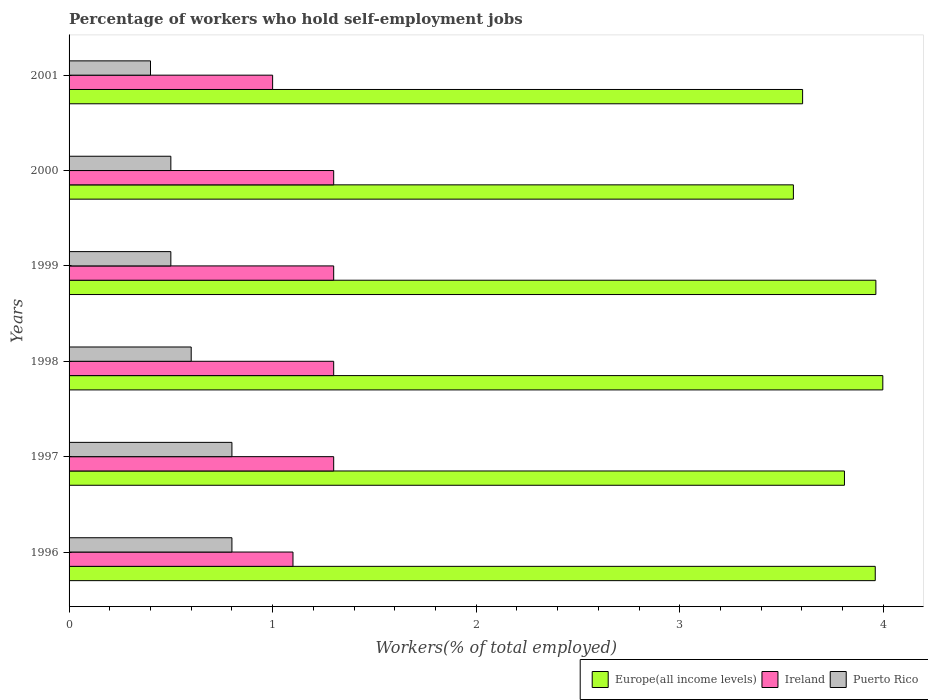How many different coloured bars are there?
Give a very brief answer. 3. How many bars are there on the 5th tick from the top?
Keep it short and to the point. 3. How many bars are there on the 3rd tick from the bottom?
Your response must be concise. 3. In how many cases, is the number of bars for a given year not equal to the number of legend labels?
Offer a very short reply. 0. What is the percentage of self-employed workers in Ireland in 1999?
Offer a very short reply. 1.3. Across all years, what is the maximum percentage of self-employed workers in Puerto Rico?
Your answer should be compact. 0.8. Across all years, what is the minimum percentage of self-employed workers in Europe(all income levels)?
Offer a terse response. 3.56. In which year was the percentage of self-employed workers in Puerto Rico maximum?
Ensure brevity in your answer.  1996. In which year was the percentage of self-employed workers in Ireland minimum?
Offer a terse response. 2001. What is the total percentage of self-employed workers in Europe(all income levels) in the graph?
Offer a very short reply. 22.89. What is the difference between the percentage of self-employed workers in Europe(all income levels) in 1996 and the percentage of self-employed workers in Puerto Rico in 1997?
Give a very brief answer. 3.16. What is the average percentage of self-employed workers in Puerto Rico per year?
Provide a short and direct response. 0.6. In the year 2001, what is the difference between the percentage of self-employed workers in Puerto Rico and percentage of self-employed workers in Ireland?
Offer a terse response. -0.6. In how many years, is the percentage of self-employed workers in Europe(all income levels) greater than 1.4 %?
Offer a terse response. 6. What is the ratio of the percentage of self-employed workers in Europe(all income levels) in 1996 to that in 1997?
Give a very brief answer. 1.04. What is the difference between the highest and the lowest percentage of self-employed workers in Ireland?
Offer a terse response. 0.3. What does the 1st bar from the top in 1997 represents?
Make the answer very short. Puerto Rico. What does the 3rd bar from the bottom in 2001 represents?
Keep it short and to the point. Puerto Rico. Is it the case that in every year, the sum of the percentage of self-employed workers in Europe(all income levels) and percentage of self-employed workers in Ireland is greater than the percentage of self-employed workers in Puerto Rico?
Provide a succinct answer. Yes. How many bars are there?
Your answer should be compact. 18. Does the graph contain any zero values?
Ensure brevity in your answer.  No. Does the graph contain grids?
Your answer should be compact. No. How are the legend labels stacked?
Make the answer very short. Horizontal. What is the title of the graph?
Give a very brief answer. Percentage of workers who hold self-employment jobs. Does "Kiribati" appear as one of the legend labels in the graph?
Offer a terse response. No. What is the label or title of the X-axis?
Provide a short and direct response. Workers(% of total employed). What is the Workers(% of total employed) of Europe(all income levels) in 1996?
Provide a succinct answer. 3.96. What is the Workers(% of total employed) of Ireland in 1996?
Your answer should be very brief. 1.1. What is the Workers(% of total employed) in Puerto Rico in 1996?
Ensure brevity in your answer.  0.8. What is the Workers(% of total employed) of Europe(all income levels) in 1997?
Ensure brevity in your answer.  3.81. What is the Workers(% of total employed) in Ireland in 1997?
Offer a terse response. 1.3. What is the Workers(% of total employed) in Puerto Rico in 1997?
Your response must be concise. 0.8. What is the Workers(% of total employed) of Europe(all income levels) in 1998?
Offer a terse response. 4. What is the Workers(% of total employed) in Ireland in 1998?
Your answer should be compact. 1.3. What is the Workers(% of total employed) in Puerto Rico in 1998?
Your answer should be compact. 0.6. What is the Workers(% of total employed) in Europe(all income levels) in 1999?
Offer a terse response. 3.96. What is the Workers(% of total employed) of Ireland in 1999?
Offer a very short reply. 1.3. What is the Workers(% of total employed) in Puerto Rico in 1999?
Make the answer very short. 0.5. What is the Workers(% of total employed) in Europe(all income levels) in 2000?
Provide a succinct answer. 3.56. What is the Workers(% of total employed) in Ireland in 2000?
Ensure brevity in your answer.  1.3. What is the Workers(% of total employed) in Europe(all income levels) in 2001?
Your response must be concise. 3.6. What is the Workers(% of total employed) of Puerto Rico in 2001?
Your response must be concise. 0.4. Across all years, what is the maximum Workers(% of total employed) in Europe(all income levels)?
Your answer should be very brief. 4. Across all years, what is the maximum Workers(% of total employed) in Ireland?
Offer a very short reply. 1.3. Across all years, what is the maximum Workers(% of total employed) of Puerto Rico?
Give a very brief answer. 0.8. Across all years, what is the minimum Workers(% of total employed) in Europe(all income levels)?
Your response must be concise. 3.56. Across all years, what is the minimum Workers(% of total employed) in Puerto Rico?
Offer a very short reply. 0.4. What is the total Workers(% of total employed) of Europe(all income levels) in the graph?
Your answer should be compact. 22.89. What is the difference between the Workers(% of total employed) in Europe(all income levels) in 1996 and that in 1997?
Offer a very short reply. 0.15. What is the difference between the Workers(% of total employed) of Ireland in 1996 and that in 1997?
Your response must be concise. -0.2. What is the difference between the Workers(% of total employed) of Europe(all income levels) in 1996 and that in 1998?
Offer a terse response. -0.04. What is the difference between the Workers(% of total employed) in Puerto Rico in 1996 and that in 1998?
Give a very brief answer. 0.2. What is the difference between the Workers(% of total employed) in Europe(all income levels) in 1996 and that in 1999?
Your response must be concise. -0. What is the difference between the Workers(% of total employed) of Ireland in 1996 and that in 1999?
Provide a succinct answer. -0.2. What is the difference between the Workers(% of total employed) in Europe(all income levels) in 1996 and that in 2000?
Provide a succinct answer. 0.4. What is the difference between the Workers(% of total employed) in Ireland in 1996 and that in 2000?
Your response must be concise. -0.2. What is the difference between the Workers(% of total employed) of Europe(all income levels) in 1996 and that in 2001?
Your answer should be very brief. 0.36. What is the difference between the Workers(% of total employed) in Europe(all income levels) in 1997 and that in 1998?
Your answer should be compact. -0.19. What is the difference between the Workers(% of total employed) in Ireland in 1997 and that in 1998?
Provide a succinct answer. 0. What is the difference between the Workers(% of total employed) in Europe(all income levels) in 1997 and that in 1999?
Provide a succinct answer. -0.15. What is the difference between the Workers(% of total employed) of Puerto Rico in 1997 and that in 1999?
Your answer should be very brief. 0.3. What is the difference between the Workers(% of total employed) of Europe(all income levels) in 1997 and that in 2000?
Offer a very short reply. 0.25. What is the difference between the Workers(% of total employed) in Ireland in 1997 and that in 2000?
Provide a succinct answer. 0. What is the difference between the Workers(% of total employed) of Europe(all income levels) in 1997 and that in 2001?
Provide a short and direct response. 0.21. What is the difference between the Workers(% of total employed) of Europe(all income levels) in 1998 and that in 1999?
Make the answer very short. 0.03. What is the difference between the Workers(% of total employed) of Ireland in 1998 and that in 1999?
Make the answer very short. 0. What is the difference between the Workers(% of total employed) in Europe(all income levels) in 1998 and that in 2000?
Your response must be concise. 0.44. What is the difference between the Workers(% of total employed) of Ireland in 1998 and that in 2000?
Keep it short and to the point. 0. What is the difference between the Workers(% of total employed) in Puerto Rico in 1998 and that in 2000?
Provide a short and direct response. 0.1. What is the difference between the Workers(% of total employed) in Europe(all income levels) in 1998 and that in 2001?
Ensure brevity in your answer.  0.39. What is the difference between the Workers(% of total employed) in Europe(all income levels) in 1999 and that in 2000?
Make the answer very short. 0.41. What is the difference between the Workers(% of total employed) of Puerto Rico in 1999 and that in 2000?
Offer a terse response. 0. What is the difference between the Workers(% of total employed) of Europe(all income levels) in 1999 and that in 2001?
Your answer should be very brief. 0.36. What is the difference between the Workers(% of total employed) of Europe(all income levels) in 2000 and that in 2001?
Give a very brief answer. -0.05. What is the difference between the Workers(% of total employed) of Puerto Rico in 2000 and that in 2001?
Your answer should be very brief. 0.1. What is the difference between the Workers(% of total employed) of Europe(all income levels) in 1996 and the Workers(% of total employed) of Ireland in 1997?
Give a very brief answer. 2.66. What is the difference between the Workers(% of total employed) of Europe(all income levels) in 1996 and the Workers(% of total employed) of Puerto Rico in 1997?
Ensure brevity in your answer.  3.16. What is the difference between the Workers(% of total employed) in Europe(all income levels) in 1996 and the Workers(% of total employed) in Ireland in 1998?
Your answer should be compact. 2.66. What is the difference between the Workers(% of total employed) of Europe(all income levels) in 1996 and the Workers(% of total employed) of Puerto Rico in 1998?
Keep it short and to the point. 3.36. What is the difference between the Workers(% of total employed) in Europe(all income levels) in 1996 and the Workers(% of total employed) in Ireland in 1999?
Your response must be concise. 2.66. What is the difference between the Workers(% of total employed) of Europe(all income levels) in 1996 and the Workers(% of total employed) of Puerto Rico in 1999?
Your response must be concise. 3.46. What is the difference between the Workers(% of total employed) of Europe(all income levels) in 1996 and the Workers(% of total employed) of Ireland in 2000?
Your answer should be very brief. 2.66. What is the difference between the Workers(% of total employed) of Europe(all income levels) in 1996 and the Workers(% of total employed) of Puerto Rico in 2000?
Keep it short and to the point. 3.46. What is the difference between the Workers(% of total employed) in Europe(all income levels) in 1996 and the Workers(% of total employed) in Ireland in 2001?
Provide a succinct answer. 2.96. What is the difference between the Workers(% of total employed) in Europe(all income levels) in 1996 and the Workers(% of total employed) in Puerto Rico in 2001?
Provide a succinct answer. 3.56. What is the difference between the Workers(% of total employed) of Europe(all income levels) in 1997 and the Workers(% of total employed) of Ireland in 1998?
Provide a short and direct response. 2.51. What is the difference between the Workers(% of total employed) in Europe(all income levels) in 1997 and the Workers(% of total employed) in Puerto Rico in 1998?
Provide a short and direct response. 3.21. What is the difference between the Workers(% of total employed) of Europe(all income levels) in 1997 and the Workers(% of total employed) of Ireland in 1999?
Your answer should be compact. 2.51. What is the difference between the Workers(% of total employed) in Europe(all income levels) in 1997 and the Workers(% of total employed) in Puerto Rico in 1999?
Give a very brief answer. 3.31. What is the difference between the Workers(% of total employed) of Europe(all income levels) in 1997 and the Workers(% of total employed) of Ireland in 2000?
Keep it short and to the point. 2.51. What is the difference between the Workers(% of total employed) in Europe(all income levels) in 1997 and the Workers(% of total employed) in Puerto Rico in 2000?
Make the answer very short. 3.31. What is the difference between the Workers(% of total employed) of Ireland in 1997 and the Workers(% of total employed) of Puerto Rico in 2000?
Your response must be concise. 0.8. What is the difference between the Workers(% of total employed) in Europe(all income levels) in 1997 and the Workers(% of total employed) in Ireland in 2001?
Your answer should be very brief. 2.81. What is the difference between the Workers(% of total employed) of Europe(all income levels) in 1997 and the Workers(% of total employed) of Puerto Rico in 2001?
Your response must be concise. 3.41. What is the difference between the Workers(% of total employed) in Ireland in 1997 and the Workers(% of total employed) in Puerto Rico in 2001?
Your answer should be compact. 0.9. What is the difference between the Workers(% of total employed) of Europe(all income levels) in 1998 and the Workers(% of total employed) of Ireland in 1999?
Your answer should be compact. 2.7. What is the difference between the Workers(% of total employed) in Europe(all income levels) in 1998 and the Workers(% of total employed) in Puerto Rico in 1999?
Provide a succinct answer. 3.5. What is the difference between the Workers(% of total employed) in Ireland in 1998 and the Workers(% of total employed) in Puerto Rico in 1999?
Give a very brief answer. 0.8. What is the difference between the Workers(% of total employed) of Europe(all income levels) in 1998 and the Workers(% of total employed) of Ireland in 2000?
Give a very brief answer. 2.7. What is the difference between the Workers(% of total employed) of Europe(all income levels) in 1998 and the Workers(% of total employed) of Puerto Rico in 2000?
Your answer should be very brief. 3.5. What is the difference between the Workers(% of total employed) in Ireland in 1998 and the Workers(% of total employed) in Puerto Rico in 2000?
Offer a terse response. 0.8. What is the difference between the Workers(% of total employed) of Europe(all income levels) in 1998 and the Workers(% of total employed) of Ireland in 2001?
Offer a terse response. 3. What is the difference between the Workers(% of total employed) of Europe(all income levels) in 1998 and the Workers(% of total employed) of Puerto Rico in 2001?
Provide a succinct answer. 3.6. What is the difference between the Workers(% of total employed) of Ireland in 1998 and the Workers(% of total employed) of Puerto Rico in 2001?
Your answer should be compact. 0.9. What is the difference between the Workers(% of total employed) of Europe(all income levels) in 1999 and the Workers(% of total employed) of Ireland in 2000?
Offer a terse response. 2.66. What is the difference between the Workers(% of total employed) in Europe(all income levels) in 1999 and the Workers(% of total employed) in Puerto Rico in 2000?
Offer a terse response. 3.46. What is the difference between the Workers(% of total employed) in Ireland in 1999 and the Workers(% of total employed) in Puerto Rico in 2000?
Provide a succinct answer. 0.8. What is the difference between the Workers(% of total employed) of Europe(all income levels) in 1999 and the Workers(% of total employed) of Ireland in 2001?
Your answer should be very brief. 2.96. What is the difference between the Workers(% of total employed) in Europe(all income levels) in 1999 and the Workers(% of total employed) in Puerto Rico in 2001?
Offer a terse response. 3.56. What is the difference between the Workers(% of total employed) in Europe(all income levels) in 2000 and the Workers(% of total employed) in Ireland in 2001?
Offer a very short reply. 2.56. What is the difference between the Workers(% of total employed) in Europe(all income levels) in 2000 and the Workers(% of total employed) in Puerto Rico in 2001?
Your response must be concise. 3.16. What is the average Workers(% of total employed) in Europe(all income levels) per year?
Keep it short and to the point. 3.82. What is the average Workers(% of total employed) of Ireland per year?
Your answer should be very brief. 1.22. What is the average Workers(% of total employed) of Puerto Rico per year?
Give a very brief answer. 0.6. In the year 1996, what is the difference between the Workers(% of total employed) in Europe(all income levels) and Workers(% of total employed) in Ireland?
Provide a short and direct response. 2.86. In the year 1996, what is the difference between the Workers(% of total employed) of Europe(all income levels) and Workers(% of total employed) of Puerto Rico?
Keep it short and to the point. 3.16. In the year 1997, what is the difference between the Workers(% of total employed) of Europe(all income levels) and Workers(% of total employed) of Ireland?
Your response must be concise. 2.51. In the year 1997, what is the difference between the Workers(% of total employed) in Europe(all income levels) and Workers(% of total employed) in Puerto Rico?
Offer a terse response. 3.01. In the year 1997, what is the difference between the Workers(% of total employed) of Ireland and Workers(% of total employed) of Puerto Rico?
Keep it short and to the point. 0.5. In the year 1998, what is the difference between the Workers(% of total employed) in Europe(all income levels) and Workers(% of total employed) in Ireland?
Your answer should be compact. 2.7. In the year 1998, what is the difference between the Workers(% of total employed) in Europe(all income levels) and Workers(% of total employed) in Puerto Rico?
Provide a succinct answer. 3.4. In the year 1998, what is the difference between the Workers(% of total employed) in Ireland and Workers(% of total employed) in Puerto Rico?
Your answer should be compact. 0.7. In the year 1999, what is the difference between the Workers(% of total employed) in Europe(all income levels) and Workers(% of total employed) in Ireland?
Your answer should be compact. 2.66. In the year 1999, what is the difference between the Workers(% of total employed) of Europe(all income levels) and Workers(% of total employed) of Puerto Rico?
Your answer should be compact. 3.46. In the year 1999, what is the difference between the Workers(% of total employed) of Ireland and Workers(% of total employed) of Puerto Rico?
Your answer should be very brief. 0.8. In the year 2000, what is the difference between the Workers(% of total employed) of Europe(all income levels) and Workers(% of total employed) of Ireland?
Provide a short and direct response. 2.26. In the year 2000, what is the difference between the Workers(% of total employed) in Europe(all income levels) and Workers(% of total employed) in Puerto Rico?
Ensure brevity in your answer.  3.06. In the year 2001, what is the difference between the Workers(% of total employed) in Europe(all income levels) and Workers(% of total employed) in Ireland?
Keep it short and to the point. 2.6. In the year 2001, what is the difference between the Workers(% of total employed) of Europe(all income levels) and Workers(% of total employed) of Puerto Rico?
Make the answer very short. 3.2. In the year 2001, what is the difference between the Workers(% of total employed) of Ireland and Workers(% of total employed) of Puerto Rico?
Your response must be concise. 0.6. What is the ratio of the Workers(% of total employed) in Europe(all income levels) in 1996 to that in 1997?
Give a very brief answer. 1.04. What is the ratio of the Workers(% of total employed) of Ireland in 1996 to that in 1997?
Offer a terse response. 0.85. What is the ratio of the Workers(% of total employed) of Ireland in 1996 to that in 1998?
Keep it short and to the point. 0.85. What is the ratio of the Workers(% of total employed) in Ireland in 1996 to that in 1999?
Offer a very short reply. 0.85. What is the ratio of the Workers(% of total employed) in Puerto Rico in 1996 to that in 1999?
Keep it short and to the point. 1.6. What is the ratio of the Workers(% of total employed) in Europe(all income levels) in 1996 to that in 2000?
Provide a short and direct response. 1.11. What is the ratio of the Workers(% of total employed) in Ireland in 1996 to that in 2000?
Keep it short and to the point. 0.85. What is the ratio of the Workers(% of total employed) of Europe(all income levels) in 1996 to that in 2001?
Give a very brief answer. 1.1. What is the ratio of the Workers(% of total employed) in Ireland in 1996 to that in 2001?
Your response must be concise. 1.1. What is the ratio of the Workers(% of total employed) of Europe(all income levels) in 1997 to that in 1998?
Offer a very short reply. 0.95. What is the ratio of the Workers(% of total employed) of Ireland in 1997 to that in 1998?
Ensure brevity in your answer.  1. What is the ratio of the Workers(% of total employed) of Puerto Rico in 1997 to that in 1998?
Give a very brief answer. 1.33. What is the ratio of the Workers(% of total employed) of Europe(all income levels) in 1997 to that in 1999?
Your answer should be very brief. 0.96. What is the ratio of the Workers(% of total employed) of Ireland in 1997 to that in 1999?
Make the answer very short. 1. What is the ratio of the Workers(% of total employed) in Europe(all income levels) in 1997 to that in 2000?
Your answer should be compact. 1.07. What is the ratio of the Workers(% of total employed) of Europe(all income levels) in 1997 to that in 2001?
Keep it short and to the point. 1.06. What is the ratio of the Workers(% of total employed) of Puerto Rico in 1997 to that in 2001?
Your answer should be compact. 2. What is the ratio of the Workers(% of total employed) in Europe(all income levels) in 1998 to that in 1999?
Keep it short and to the point. 1.01. What is the ratio of the Workers(% of total employed) of Puerto Rico in 1998 to that in 1999?
Offer a terse response. 1.2. What is the ratio of the Workers(% of total employed) in Europe(all income levels) in 1998 to that in 2000?
Provide a short and direct response. 1.12. What is the ratio of the Workers(% of total employed) in Ireland in 1998 to that in 2000?
Make the answer very short. 1. What is the ratio of the Workers(% of total employed) of Puerto Rico in 1998 to that in 2000?
Your response must be concise. 1.2. What is the ratio of the Workers(% of total employed) in Europe(all income levels) in 1998 to that in 2001?
Provide a succinct answer. 1.11. What is the ratio of the Workers(% of total employed) in Ireland in 1998 to that in 2001?
Your response must be concise. 1.3. What is the ratio of the Workers(% of total employed) in Europe(all income levels) in 1999 to that in 2000?
Ensure brevity in your answer.  1.11. What is the ratio of the Workers(% of total employed) of Ireland in 1999 to that in 2000?
Your answer should be very brief. 1. What is the ratio of the Workers(% of total employed) in Puerto Rico in 1999 to that in 2000?
Ensure brevity in your answer.  1. What is the ratio of the Workers(% of total employed) of Europe(all income levels) in 1999 to that in 2001?
Ensure brevity in your answer.  1.1. What is the ratio of the Workers(% of total employed) of Puerto Rico in 1999 to that in 2001?
Your answer should be compact. 1.25. What is the ratio of the Workers(% of total employed) in Europe(all income levels) in 2000 to that in 2001?
Provide a short and direct response. 0.99. What is the difference between the highest and the second highest Workers(% of total employed) in Europe(all income levels)?
Offer a terse response. 0.03. What is the difference between the highest and the second highest Workers(% of total employed) in Ireland?
Give a very brief answer. 0. What is the difference between the highest and the lowest Workers(% of total employed) in Europe(all income levels)?
Ensure brevity in your answer.  0.44. What is the difference between the highest and the lowest Workers(% of total employed) in Ireland?
Give a very brief answer. 0.3. What is the difference between the highest and the lowest Workers(% of total employed) of Puerto Rico?
Your answer should be compact. 0.4. 